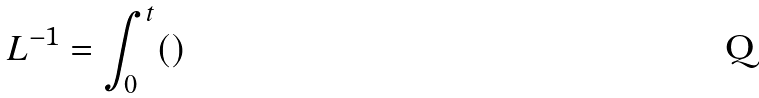Convert formula to latex. <formula><loc_0><loc_0><loc_500><loc_500>L ^ { - 1 } = \int _ { 0 } ^ { t } ( )</formula> 